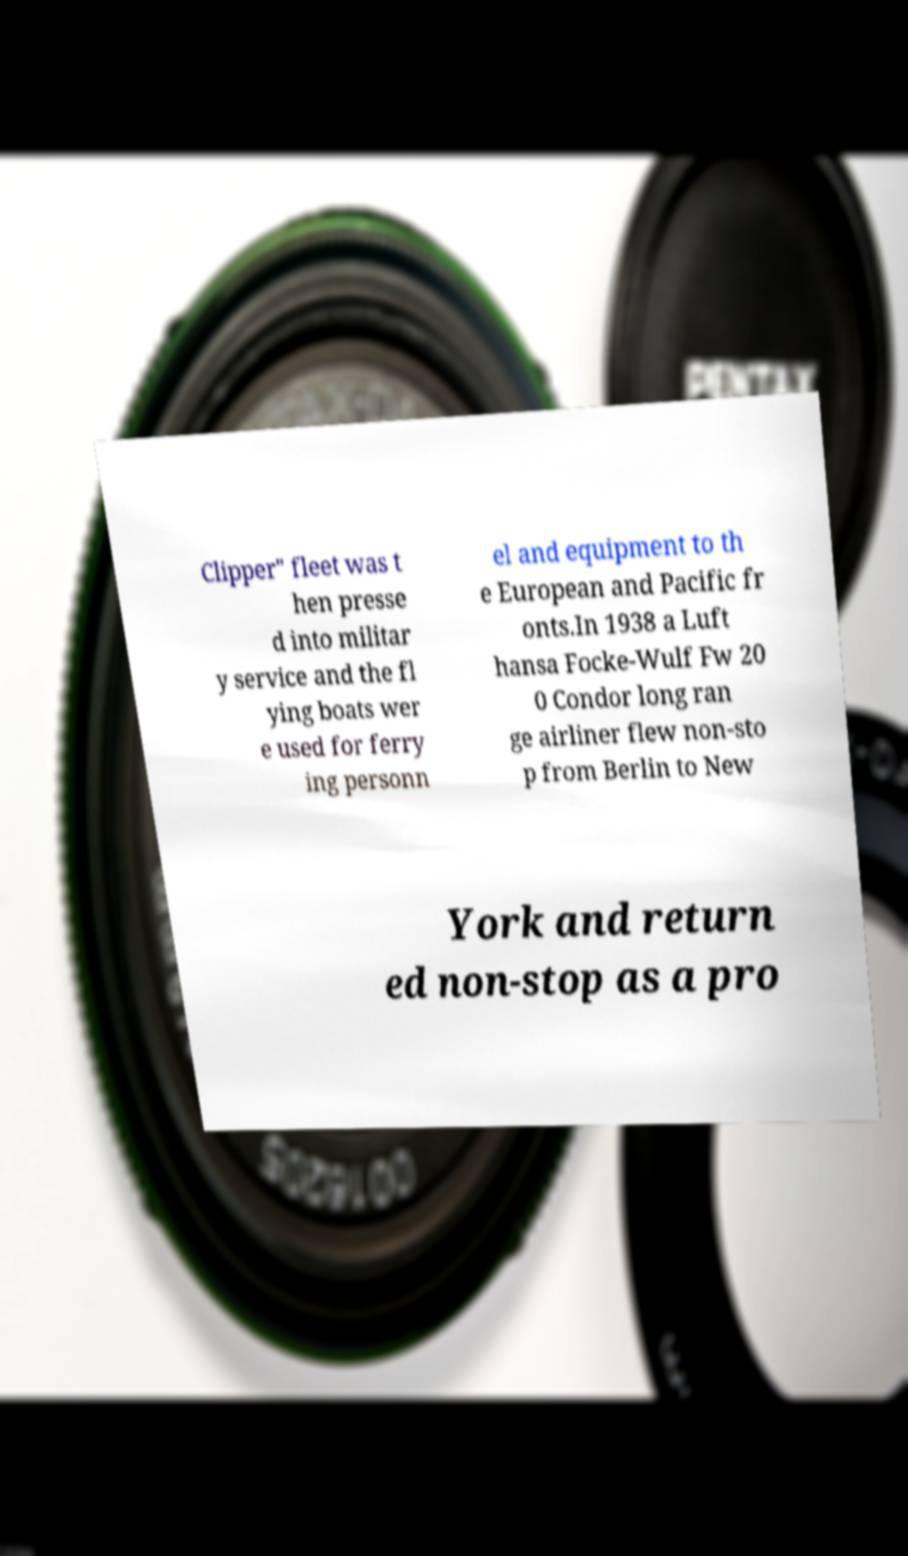Can you read and provide the text displayed in the image?This photo seems to have some interesting text. Can you extract and type it out for me? Clipper" fleet was t hen presse d into militar y service and the fl ying boats wer e used for ferry ing personn el and equipment to th e European and Pacific fr onts.In 1938 a Luft hansa Focke-Wulf Fw 20 0 Condor long ran ge airliner flew non-sto p from Berlin to New York and return ed non-stop as a pro 